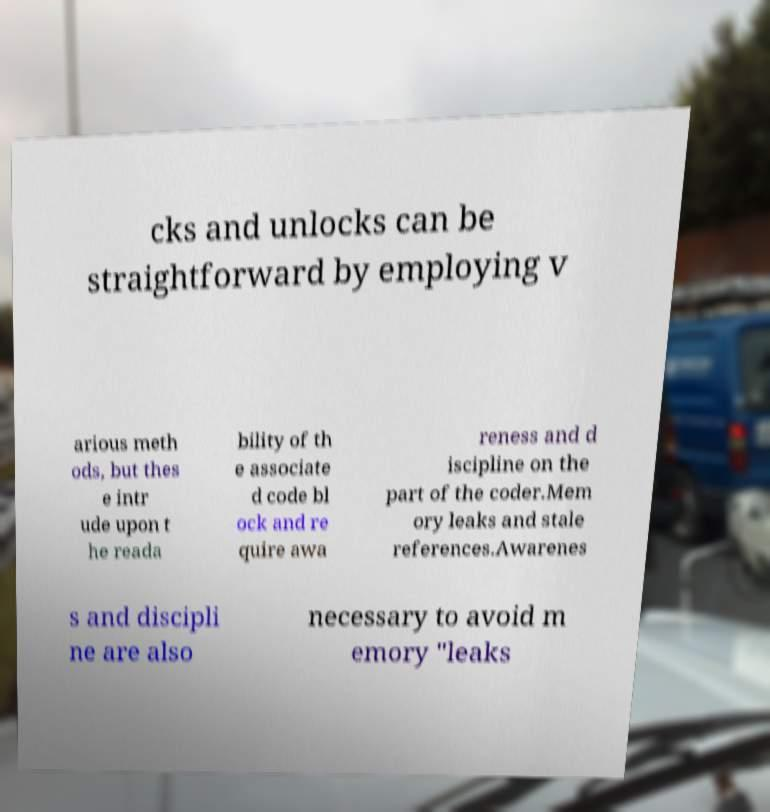Please read and relay the text visible in this image. What does it say? cks and unlocks can be straightforward by employing v arious meth ods, but thes e intr ude upon t he reada bility of th e associate d code bl ock and re quire awa reness and d iscipline on the part of the coder.Mem ory leaks and stale references.Awarenes s and discipli ne are also necessary to avoid m emory "leaks 